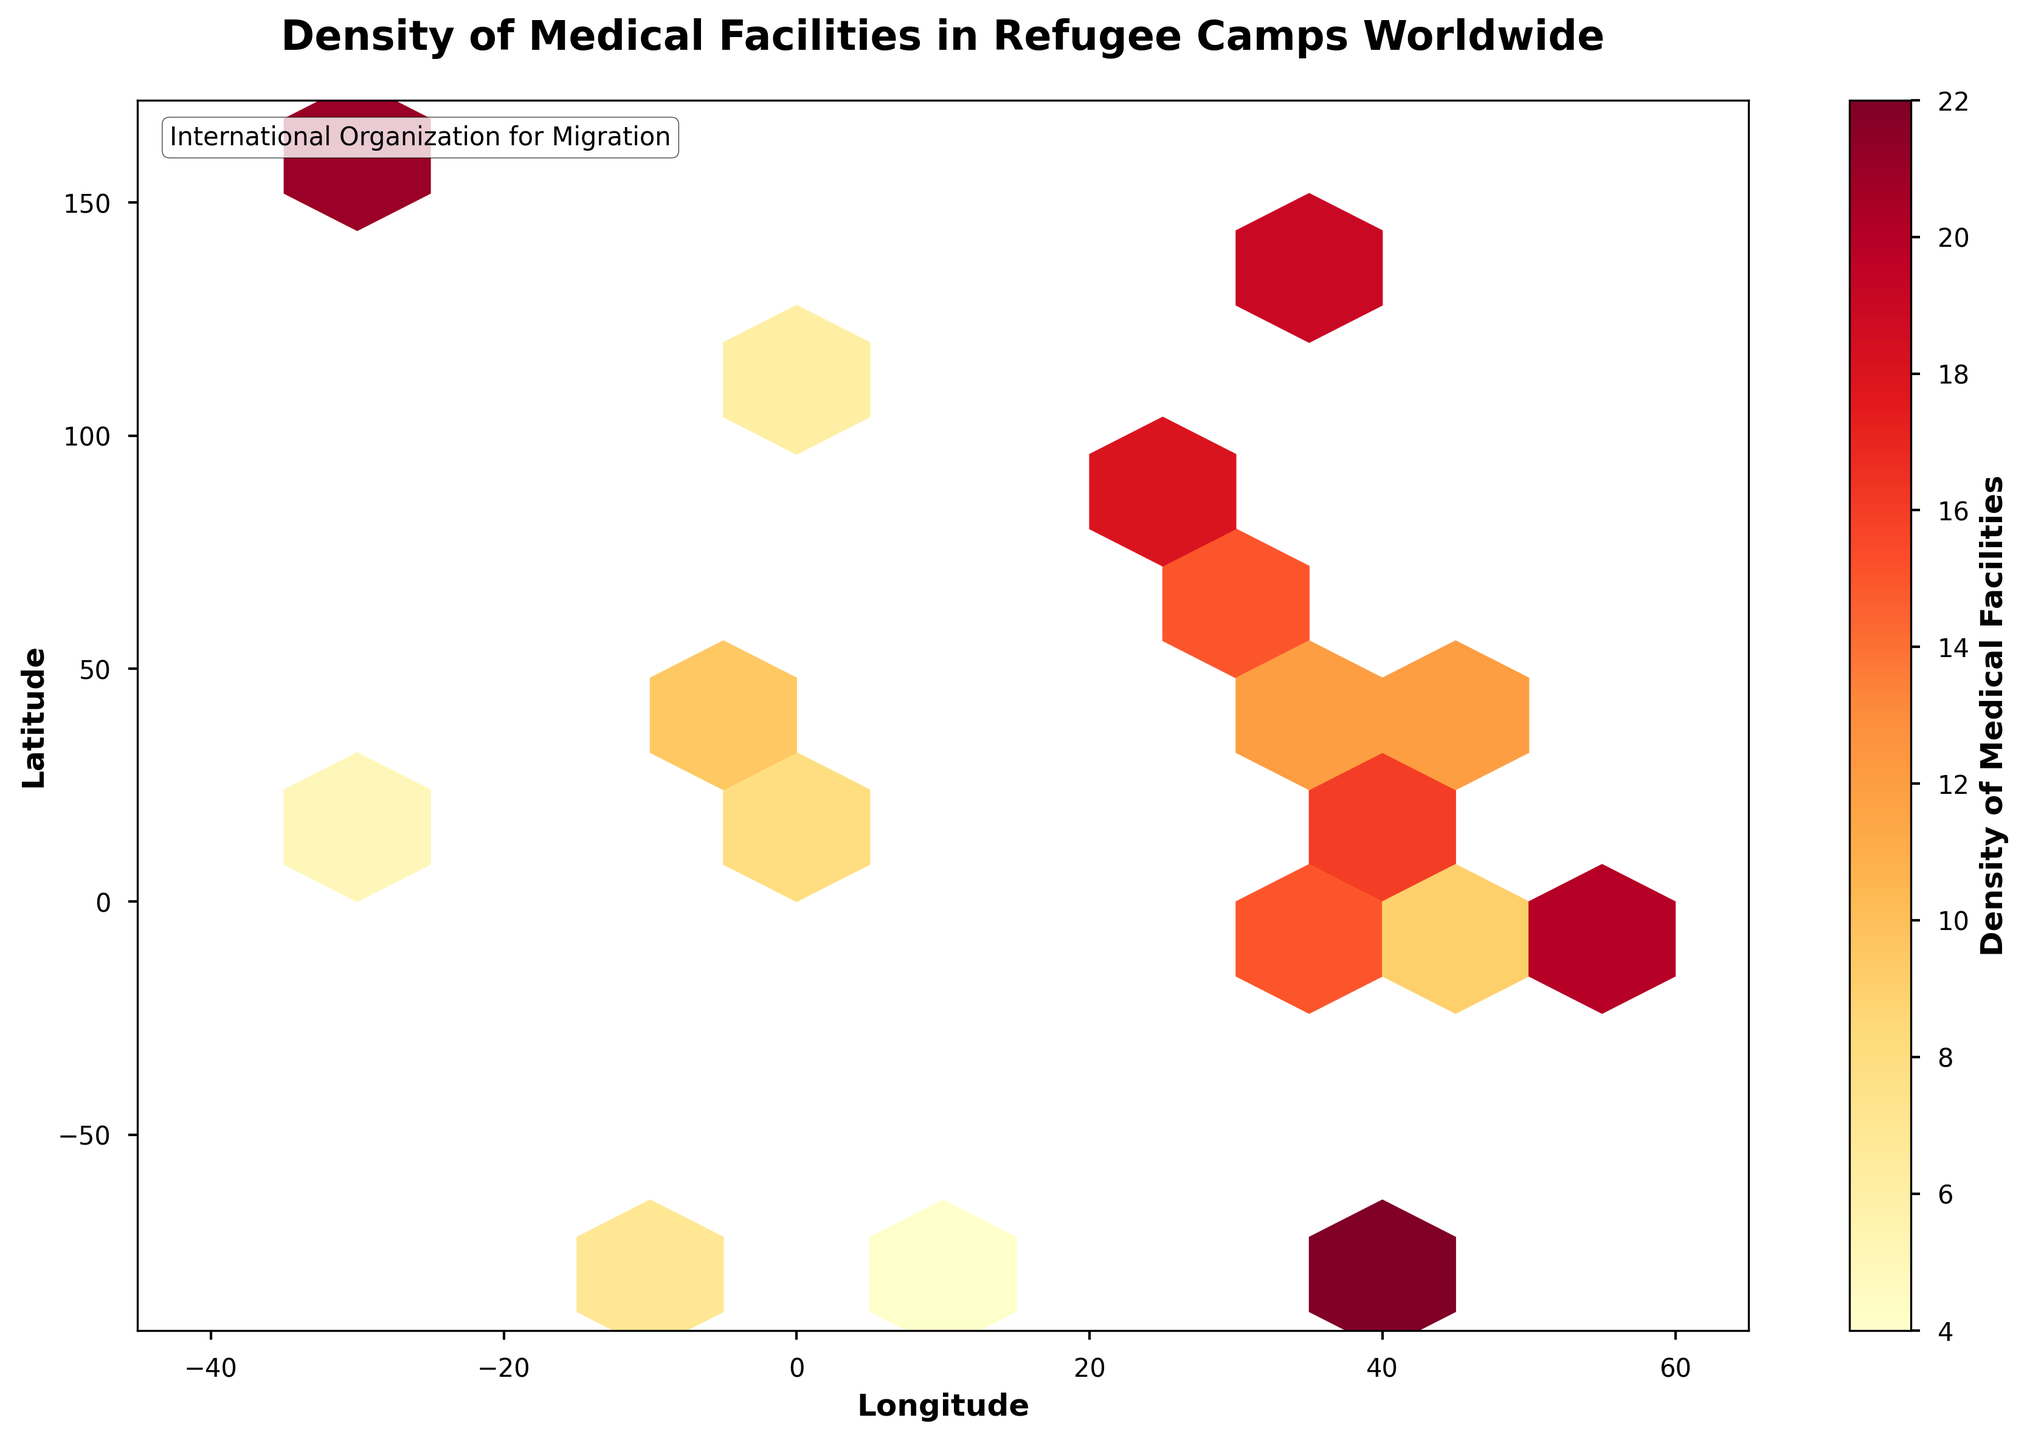What is the title of the hexbin plot? The title of the hexbin plot is a basic element that is usually found at the top of the figure. Looking there will provide the direct answer.
Answer: Density of Medical Facilities in Refugee Camps Worldwide What does the color bar represent? The color bar in a hexbin plot typically indicates the variable that is being visualized. In this case, the label on the color bar will provide the answer.
Answer: Density of Medical Facilities What is the range of the longitude axis? The x-axis label would denote the longitude range, which can be read directly from the axis. Check for the minimum and maximum values.
Answer: -40 to 60 Which longitude has the highest density of medical facilities? In a hexbin plot, the highest density is shown by the darkest color. Locate the bin with the darkest shade and note its corresponding longitude.
Answer: 40.7 What is the general relationship between latitude and density of medical facilities? This requires observing whether higher latitudes tend to correlate with higher densities, which is visually noticeable from the density distribution across latitudes.
Answer: Higher densities are mostly at mid to high latitudes How does the density of medical facilities at 35.8, -6.2 compare to those at 40.7, -74.0? Locate the corresponding bins for each coordinate on the plot and compare their colors to determine the relative densities.
Answer: The density at 40.7, -74.0 is higher Which region appears to have the most scattered medical facilities based on latitude? Look for the range with the most widespread colored hexagons along the latitude axis. This will indicate scattered facilities.
Answer: -80 to 90 Is there a concentration of higher densities in any particular region? By observing the plot, identify if any specific area shows a cluster of darker hexagons indicating higher density.
Answer: High densities are concentrated around 30-40 latitude and 130-150 longitude Between the latitudes of 20 and 40, which longitude has the most medical facilities? Focus on the bins within the specified latitude range and identify the one with the darkest color corresponding to longitude.
Answer: 40.7 